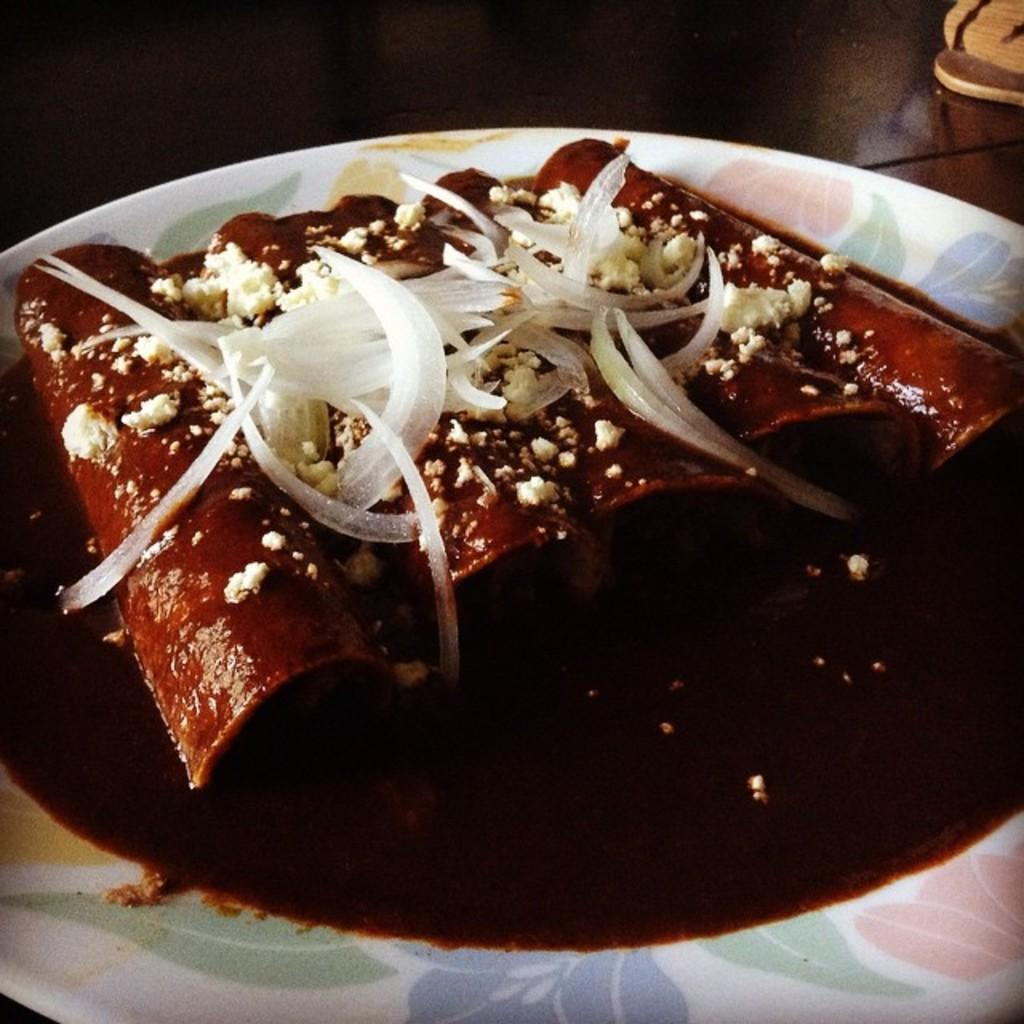What is present on the plate in the image? There is food on the plate in the image. What type of surface is visible at the bottom of the image? There is a wooden surface visible at the bottom of the image. What type of skirt is visible in the image? There is no skirt present in the image. What type of jeans is visible in the image? There is no jeans present in the image. 